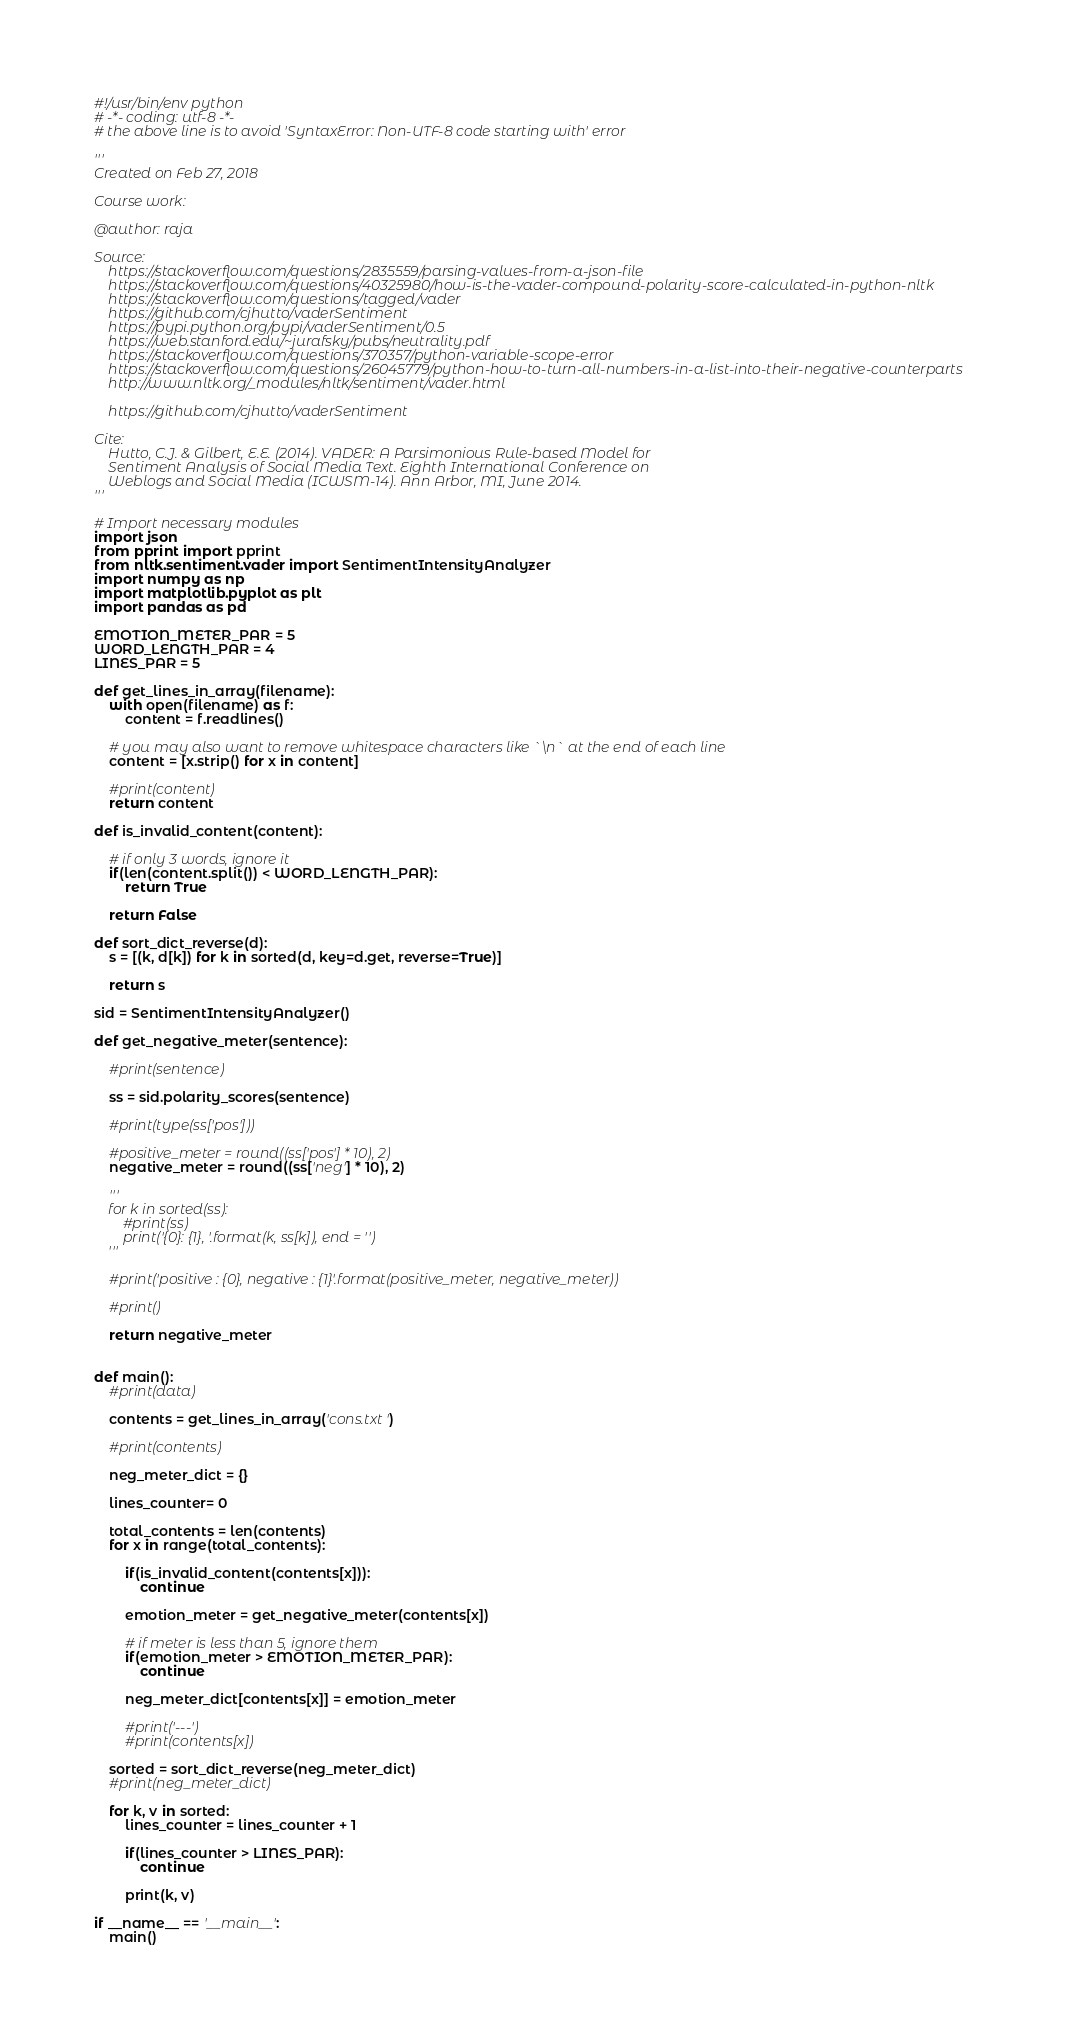Convert code to text. <code><loc_0><loc_0><loc_500><loc_500><_Python_>#!/usr/bin/env python
# -*- coding: utf-8 -*-
# the above line is to avoid 'SyntaxError: Non-UTF-8 code starting with' error

'''
Created on Feb 27, 2018

Course work: 

@author: raja

Source:
    https://stackoverflow.com/questions/2835559/parsing-values-from-a-json-file
    https://stackoverflow.com/questions/40325980/how-is-the-vader-compound-polarity-score-calculated-in-python-nltk
    https://stackoverflow.com/questions/tagged/vader
    https://github.com/cjhutto/vaderSentiment
    https://pypi.python.org/pypi/vaderSentiment/0.5
    https://web.stanford.edu/~jurafsky/pubs/neutrality.pdf
    https://stackoverflow.com/questions/370357/python-variable-scope-error
    https://stackoverflow.com/questions/26045779/python-how-to-turn-all-numbers-in-a-list-into-their-negative-counterparts
    http://www.nltk.org/_modules/nltk/sentiment/vader.html
    
    https://github.com/cjhutto/vaderSentiment
    
Cite:
    Hutto, C.J. & Gilbert, E.E. (2014). VADER: A Parsimonious Rule-based Model for
    Sentiment Analysis of Social Media Text. Eighth International Conference on
    Weblogs and Social Media (ICWSM-14). Ann Arbor, MI, June 2014.
'''

# Import necessary modules
import json
from pprint import pprint
from nltk.sentiment.vader import SentimentIntensityAnalyzer
import numpy as np
import matplotlib.pyplot as plt
import pandas as pd

EMOTION_METER_PAR = 5
WORD_LENGTH_PAR = 4
LINES_PAR = 5

def get_lines_in_array(filename):    
    with open(filename) as f:
        content = f.readlines()
        
    # you may also want to remove whitespace characters like `\n` at the end of each line
    content = [x.strip() for x in content]
    
    #print(content)  
    return content

def is_invalid_content(content):
    
    # if only 3 words, ignore it
    if(len(content.split()) < WORD_LENGTH_PAR):
        return True
    
    return False

def sort_dict_reverse(d):
    s = [(k, d[k]) for k in sorted(d, key=d.get, reverse=True)]
    
    return s

sid = SentimentIntensityAnalyzer()

def get_negative_meter(sentence):
        
    #print(sentence)

    ss = sid.polarity_scores(sentence)
    
    #print(type(ss['pos']))

    #positive_meter = round((ss['pos'] * 10), 2) 
    negative_meter = round((ss['neg'] * 10), 2)
    
    '''
    for k in sorted(ss):
        #print(ss)
        print('{0}: {1}, '.format(k, ss[k]), end = '')
    '''
    
    #print('positive : {0}, negative : {1}'.format(positive_meter, negative_meter))
    
    #print()
    
    return negative_meter

    
def main():    
    #print(data)
    
    contents = get_lines_in_array('cons.txt')
    
    #print(contents)
    
    neg_meter_dict = {}
    
    lines_counter= 0
    
    total_contents = len(contents)
    for x in range(total_contents):
        
        if(is_invalid_content(contents[x])):
            continue
        
        emotion_meter = get_negative_meter(contents[x])
        
        # if meter is less than 5, ignore them
        if(emotion_meter > EMOTION_METER_PAR):
            continue
        
        neg_meter_dict[contents[x]] = emotion_meter
        
        #print('---')
        #print(contents[x])        
        
    sorted = sort_dict_reverse(neg_meter_dict)    
    #print(neg_meter_dict)
    
    for k, v in sorted:
        lines_counter = lines_counter + 1
        
        if(lines_counter > LINES_PAR):
            continue                

        print(k, v)
    
if __name__ == '__main__':
    main()</code> 